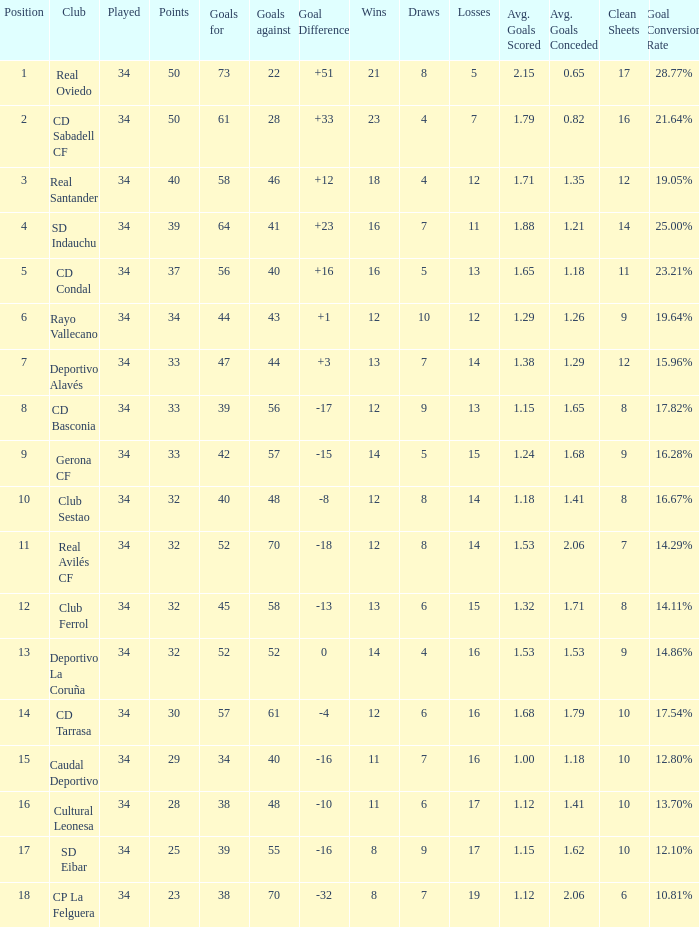How many Goals against have Played more than 34? 0.0. Parse the full table. {'header': ['Position', 'Club', 'Played', 'Points', 'Goals for', 'Goals against', 'Goal Difference', 'Wins', 'Draws', 'Losses', 'Avg. Goals Scored', 'Avg. Goals Conceded', 'Clean Sheets', 'Goal Conversion Rate'], 'rows': [['1', 'Real Oviedo', '34', '50', '73', '22', '+51', '21', '8', '5', '2.15', '0.65', '17', '28.77%'], ['2', 'CD Sabadell CF', '34', '50', '61', '28', '+33', '23', '4', '7', '1.79', '0.82', '16', '21.64%'], ['3', 'Real Santander', '34', '40', '58', '46', '+12', '18', '4', '12', '1.71', '1.35', '12', '19.05%'], ['4', 'SD Indauchu', '34', '39', '64', '41', '+23', '16', '7', '11', '1.88', '1.21', '14', '25.00%'], ['5', 'CD Condal', '34', '37', '56', '40', '+16', '16', '5', '13', '1.65', '1.18', '11', '23.21%'], ['6', 'Rayo Vallecano', '34', '34', '44', '43', '+1', '12', '10', '12', '1.29', '1.26', '9', '19.64%'], ['7', 'Deportivo Alavés', '34', '33', '47', '44', '+3', '13', '7', '14', '1.38', '1.29', '12', '15.96%'], ['8', 'CD Basconia', '34', '33', '39', '56', '-17', '12', '9', '13', '1.15', '1.65', '8', '17.82%'], ['9', 'Gerona CF', '34', '33', '42', '57', '-15', '14', '5', '15', '1.24', '1.68', '9', '16.28%'], ['10', 'Club Sestao', '34', '32', '40', '48', '-8', '12', '8', '14', '1.18', '1.41', '8', '16.67%'], ['11', 'Real Avilés CF', '34', '32', '52', '70', '-18', '12', '8', '14', '1.53', '2.06', '7', '14.29%'], ['12', 'Club Ferrol', '34', '32', '45', '58', '-13', '13', '6', '15', '1.32', '1.71', '8', '14.11%'], ['13', 'Deportivo La Coruña', '34', '32', '52', '52', '0', '14', '4', '16', '1.53', '1.53', '9', '14.86%'], ['14', 'CD Tarrasa', '34', '30', '57', '61', '-4', '12', '6', '16', '1.68', '1.79', '10', '17.54%'], ['15', 'Caudal Deportivo', '34', '29', '34', '40', '-16', '11', '7', '16', '1.00', '1.18', '10', '12.80%'], ['16', 'Cultural Leonesa', '34', '28', '38', '48', '-10', '11', '6', '17', '1.12', '1.41', '10', '13.70%'], ['17', 'SD Eibar', '34', '25', '39', '55', '-16', '8', '9', '17', '1.15', '1.62', '10', '12.10%'], ['18', 'CP La Felguera', '34', '23', '38', '70', '-32', '8', '7', '19', '1.12', '2.06', '6', '10.81%']]} 